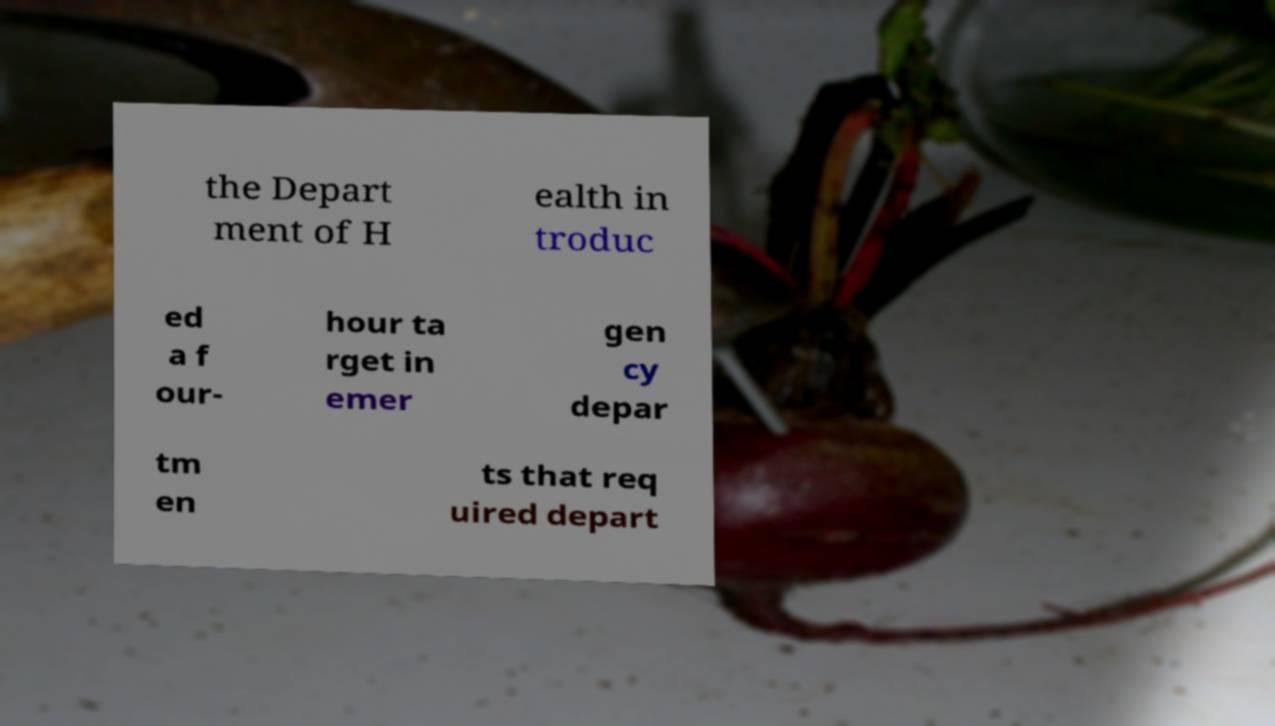Can you read and provide the text displayed in the image?This photo seems to have some interesting text. Can you extract and type it out for me? the Depart ment of H ealth in troduc ed a f our- hour ta rget in emer gen cy depar tm en ts that req uired depart 